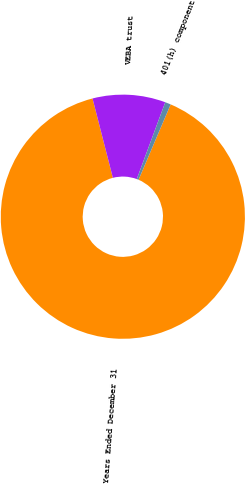Convert chart. <chart><loc_0><loc_0><loc_500><loc_500><pie_chart><fcel>Years Ended December 31<fcel>VEBA trust<fcel>401(h) component<nl><fcel>89.6%<fcel>9.64%<fcel>0.76%<nl></chart> 